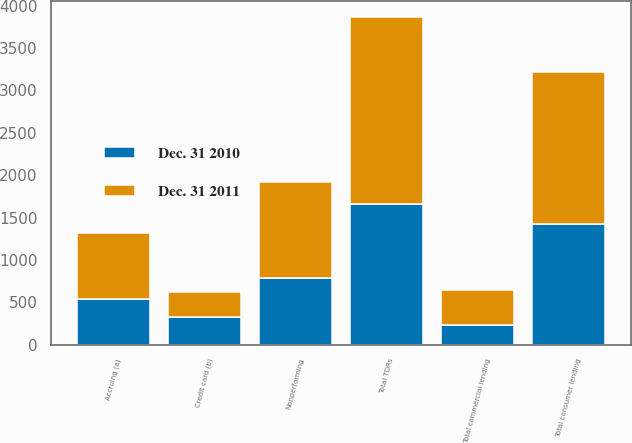<chart> <loc_0><loc_0><loc_500><loc_500><stacked_bar_chart><ecel><fcel>Total consumer lending<fcel>Total commercial lending<fcel>Total TDRs<fcel>Nonperforming<fcel>Accruing (a)<fcel>Credit card (b)<nl><fcel>Dec. 31 2011<fcel>1798<fcel>405<fcel>2203<fcel>1141<fcel>771<fcel>291<nl><fcel>Dec. 31 2010<fcel>1422<fcel>236<fcel>1658<fcel>784<fcel>543<fcel>331<nl></chart> 